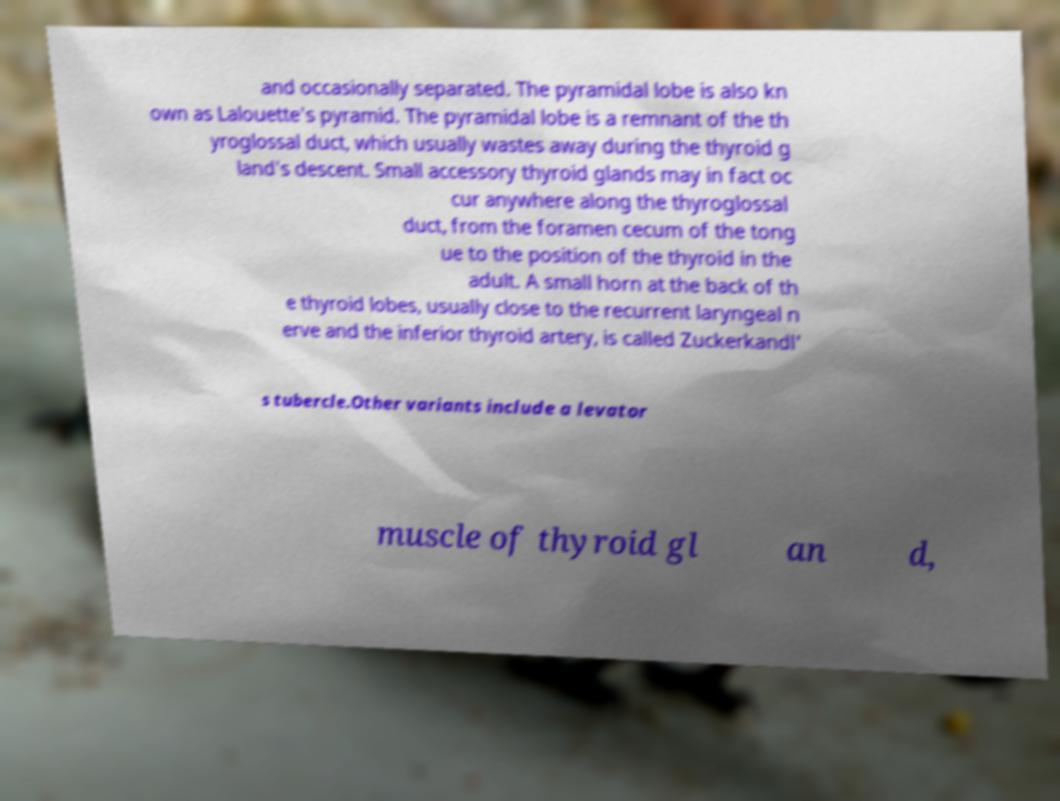Please read and relay the text visible in this image. What does it say? and occasionally separated. The pyramidal lobe is also kn own as Lalouette's pyramid. The pyramidal lobe is a remnant of the th yroglossal duct, which usually wastes away during the thyroid g land's descent. Small accessory thyroid glands may in fact oc cur anywhere along the thyroglossal duct, from the foramen cecum of the tong ue to the position of the thyroid in the adult. A small horn at the back of th e thyroid lobes, usually close to the recurrent laryngeal n erve and the inferior thyroid artery, is called Zuckerkandl' s tubercle.Other variants include a levator muscle of thyroid gl an d, 